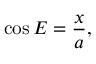<formula> <loc_0><loc_0><loc_500><loc_500>\cos E = { \frac { x } { a } } ,</formula> 